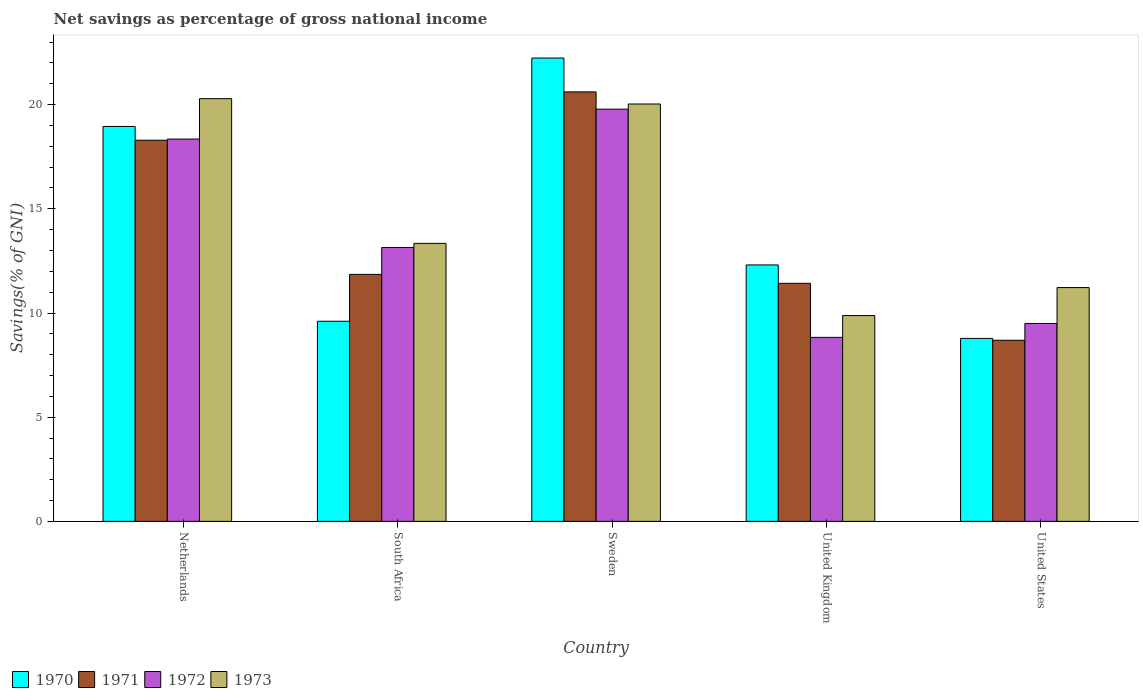How many different coloured bars are there?
Your answer should be very brief. 4. How many groups of bars are there?
Provide a succinct answer. 5. Are the number of bars on each tick of the X-axis equal?
Provide a succinct answer. Yes. What is the label of the 2nd group of bars from the left?
Your answer should be compact. South Africa. In how many cases, is the number of bars for a given country not equal to the number of legend labels?
Offer a very short reply. 0. What is the total savings in 1973 in Sweden?
Your answer should be compact. 20.03. Across all countries, what is the maximum total savings in 1973?
Give a very brief answer. 20.29. Across all countries, what is the minimum total savings in 1973?
Make the answer very short. 9.88. In which country was the total savings in 1971 maximum?
Offer a terse response. Sweden. In which country was the total savings in 1973 minimum?
Provide a short and direct response. United Kingdom. What is the total total savings in 1973 in the graph?
Offer a terse response. 74.76. What is the difference between the total savings in 1973 in South Africa and that in Sweden?
Offer a terse response. -6.69. What is the difference between the total savings in 1972 in Sweden and the total savings in 1971 in South Africa?
Provide a succinct answer. 7.93. What is the average total savings in 1971 per country?
Provide a short and direct response. 14.18. What is the difference between the total savings of/in 1973 and total savings of/in 1970 in Netherlands?
Provide a succinct answer. 1.33. What is the ratio of the total savings in 1973 in Netherlands to that in United Kingdom?
Keep it short and to the point. 2.05. Is the total savings in 1970 in United Kingdom less than that in United States?
Offer a terse response. No. What is the difference between the highest and the second highest total savings in 1970?
Your answer should be very brief. 6.65. What is the difference between the highest and the lowest total savings in 1970?
Your answer should be very brief. 13.46. Is it the case that in every country, the sum of the total savings in 1970 and total savings in 1972 is greater than the total savings in 1971?
Offer a very short reply. Yes. Are all the bars in the graph horizontal?
Ensure brevity in your answer.  No. How many countries are there in the graph?
Offer a terse response. 5. What is the difference between two consecutive major ticks on the Y-axis?
Provide a succinct answer. 5. Does the graph contain grids?
Your response must be concise. No. How many legend labels are there?
Ensure brevity in your answer.  4. What is the title of the graph?
Your answer should be very brief. Net savings as percentage of gross national income. What is the label or title of the X-axis?
Your response must be concise. Country. What is the label or title of the Y-axis?
Your answer should be very brief. Savings(% of GNI). What is the Savings(% of GNI) of 1970 in Netherlands?
Your answer should be compact. 18.95. What is the Savings(% of GNI) in 1971 in Netherlands?
Ensure brevity in your answer.  18.29. What is the Savings(% of GNI) of 1972 in Netherlands?
Your answer should be compact. 18.35. What is the Savings(% of GNI) of 1973 in Netherlands?
Offer a very short reply. 20.29. What is the Savings(% of GNI) of 1970 in South Africa?
Provide a succinct answer. 9.6. What is the Savings(% of GNI) of 1971 in South Africa?
Provide a short and direct response. 11.85. What is the Savings(% of GNI) in 1972 in South Africa?
Provide a short and direct response. 13.14. What is the Savings(% of GNI) in 1973 in South Africa?
Make the answer very short. 13.34. What is the Savings(% of GNI) in 1970 in Sweden?
Give a very brief answer. 22.24. What is the Savings(% of GNI) in 1971 in Sweden?
Ensure brevity in your answer.  20.61. What is the Savings(% of GNI) of 1972 in Sweden?
Offer a very short reply. 19.78. What is the Savings(% of GNI) in 1973 in Sweden?
Make the answer very short. 20.03. What is the Savings(% of GNI) in 1970 in United Kingdom?
Give a very brief answer. 12.31. What is the Savings(% of GNI) of 1971 in United Kingdom?
Your answer should be compact. 11.43. What is the Savings(% of GNI) of 1972 in United Kingdom?
Provide a short and direct response. 8.83. What is the Savings(% of GNI) in 1973 in United Kingdom?
Make the answer very short. 9.88. What is the Savings(% of GNI) of 1970 in United States?
Make the answer very short. 8.78. What is the Savings(% of GNI) of 1971 in United States?
Your answer should be compact. 8.69. What is the Savings(% of GNI) of 1972 in United States?
Provide a short and direct response. 9.5. What is the Savings(% of GNI) in 1973 in United States?
Offer a very short reply. 11.22. Across all countries, what is the maximum Savings(% of GNI) in 1970?
Your response must be concise. 22.24. Across all countries, what is the maximum Savings(% of GNI) of 1971?
Offer a very short reply. 20.61. Across all countries, what is the maximum Savings(% of GNI) in 1972?
Offer a terse response. 19.78. Across all countries, what is the maximum Savings(% of GNI) of 1973?
Keep it short and to the point. 20.29. Across all countries, what is the minimum Savings(% of GNI) in 1970?
Your response must be concise. 8.78. Across all countries, what is the minimum Savings(% of GNI) of 1971?
Keep it short and to the point. 8.69. Across all countries, what is the minimum Savings(% of GNI) of 1972?
Provide a short and direct response. 8.83. Across all countries, what is the minimum Savings(% of GNI) of 1973?
Make the answer very short. 9.88. What is the total Savings(% of GNI) in 1970 in the graph?
Offer a very short reply. 71.88. What is the total Savings(% of GNI) of 1971 in the graph?
Ensure brevity in your answer.  70.88. What is the total Savings(% of GNI) in 1972 in the graph?
Your response must be concise. 69.61. What is the total Savings(% of GNI) in 1973 in the graph?
Make the answer very short. 74.76. What is the difference between the Savings(% of GNI) in 1970 in Netherlands and that in South Africa?
Provide a short and direct response. 9.35. What is the difference between the Savings(% of GNI) of 1971 in Netherlands and that in South Africa?
Make the answer very short. 6.44. What is the difference between the Savings(% of GNI) of 1972 in Netherlands and that in South Africa?
Keep it short and to the point. 5.21. What is the difference between the Savings(% of GNI) in 1973 in Netherlands and that in South Africa?
Keep it short and to the point. 6.95. What is the difference between the Savings(% of GNI) in 1970 in Netherlands and that in Sweden?
Offer a terse response. -3.28. What is the difference between the Savings(% of GNI) in 1971 in Netherlands and that in Sweden?
Provide a succinct answer. -2.32. What is the difference between the Savings(% of GNI) of 1972 in Netherlands and that in Sweden?
Your answer should be compact. -1.43. What is the difference between the Savings(% of GNI) of 1973 in Netherlands and that in Sweden?
Provide a short and direct response. 0.26. What is the difference between the Savings(% of GNI) in 1970 in Netherlands and that in United Kingdom?
Your answer should be compact. 6.65. What is the difference between the Savings(% of GNI) in 1971 in Netherlands and that in United Kingdom?
Offer a very short reply. 6.87. What is the difference between the Savings(% of GNI) of 1972 in Netherlands and that in United Kingdom?
Offer a terse response. 9.52. What is the difference between the Savings(% of GNI) in 1973 in Netherlands and that in United Kingdom?
Keep it short and to the point. 10.41. What is the difference between the Savings(% of GNI) of 1970 in Netherlands and that in United States?
Make the answer very short. 10.17. What is the difference between the Savings(% of GNI) in 1971 in Netherlands and that in United States?
Provide a succinct answer. 9.6. What is the difference between the Savings(% of GNI) of 1972 in Netherlands and that in United States?
Ensure brevity in your answer.  8.85. What is the difference between the Savings(% of GNI) in 1973 in Netherlands and that in United States?
Offer a very short reply. 9.07. What is the difference between the Savings(% of GNI) of 1970 in South Africa and that in Sweden?
Your answer should be compact. -12.63. What is the difference between the Savings(% of GNI) of 1971 in South Africa and that in Sweden?
Provide a short and direct response. -8.76. What is the difference between the Savings(% of GNI) of 1972 in South Africa and that in Sweden?
Offer a terse response. -6.64. What is the difference between the Savings(% of GNI) of 1973 in South Africa and that in Sweden?
Give a very brief answer. -6.69. What is the difference between the Savings(% of GNI) of 1970 in South Africa and that in United Kingdom?
Ensure brevity in your answer.  -2.7. What is the difference between the Savings(% of GNI) in 1971 in South Africa and that in United Kingdom?
Ensure brevity in your answer.  0.43. What is the difference between the Savings(% of GNI) in 1972 in South Africa and that in United Kingdom?
Keep it short and to the point. 4.31. What is the difference between the Savings(% of GNI) in 1973 in South Africa and that in United Kingdom?
Make the answer very short. 3.46. What is the difference between the Savings(% of GNI) of 1970 in South Africa and that in United States?
Keep it short and to the point. 0.82. What is the difference between the Savings(% of GNI) of 1971 in South Africa and that in United States?
Give a very brief answer. 3.16. What is the difference between the Savings(% of GNI) of 1972 in South Africa and that in United States?
Your response must be concise. 3.65. What is the difference between the Savings(% of GNI) of 1973 in South Africa and that in United States?
Your response must be concise. 2.12. What is the difference between the Savings(% of GNI) in 1970 in Sweden and that in United Kingdom?
Make the answer very short. 9.93. What is the difference between the Savings(% of GNI) in 1971 in Sweden and that in United Kingdom?
Ensure brevity in your answer.  9.19. What is the difference between the Savings(% of GNI) in 1972 in Sweden and that in United Kingdom?
Provide a short and direct response. 10.95. What is the difference between the Savings(% of GNI) in 1973 in Sweden and that in United Kingdom?
Your answer should be compact. 10.15. What is the difference between the Savings(% of GNI) in 1970 in Sweden and that in United States?
Your answer should be very brief. 13.46. What is the difference between the Savings(% of GNI) in 1971 in Sweden and that in United States?
Keep it short and to the point. 11.92. What is the difference between the Savings(% of GNI) in 1972 in Sweden and that in United States?
Offer a very short reply. 10.29. What is the difference between the Savings(% of GNI) of 1973 in Sweden and that in United States?
Your answer should be very brief. 8.81. What is the difference between the Savings(% of GNI) of 1970 in United Kingdom and that in United States?
Your answer should be compact. 3.53. What is the difference between the Savings(% of GNI) in 1971 in United Kingdom and that in United States?
Your answer should be compact. 2.73. What is the difference between the Savings(% of GNI) in 1972 in United Kingdom and that in United States?
Provide a short and direct response. -0.67. What is the difference between the Savings(% of GNI) of 1973 in United Kingdom and that in United States?
Provide a short and direct response. -1.34. What is the difference between the Savings(% of GNI) in 1970 in Netherlands and the Savings(% of GNI) in 1971 in South Africa?
Offer a very short reply. 7.1. What is the difference between the Savings(% of GNI) in 1970 in Netherlands and the Savings(% of GNI) in 1972 in South Africa?
Your answer should be compact. 5.81. What is the difference between the Savings(% of GNI) of 1970 in Netherlands and the Savings(% of GNI) of 1973 in South Africa?
Your answer should be very brief. 5.61. What is the difference between the Savings(% of GNI) of 1971 in Netherlands and the Savings(% of GNI) of 1972 in South Africa?
Offer a very short reply. 5.15. What is the difference between the Savings(% of GNI) in 1971 in Netherlands and the Savings(% of GNI) in 1973 in South Africa?
Your response must be concise. 4.95. What is the difference between the Savings(% of GNI) in 1972 in Netherlands and the Savings(% of GNI) in 1973 in South Africa?
Ensure brevity in your answer.  5.01. What is the difference between the Savings(% of GNI) of 1970 in Netherlands and the Savings(% of GNI) of 1971 in Sweden?
Your answer should be very brief. -1.66. What is the difference between the Savings(% of GNI) in 1970 in Netherlands and the Savings(% of GNI) in 1972 in Sweden?
Make the answer very short. -0.83. What is the difference between the Savings(% of GNI) of 1970 in Netherlands and the Savings(% of GNI) of 1973 in Sweden?
Your answer should be compact. -1.08. What is the difference between the Savings(% of GNI) in 1971 in Netherlands and the Savings(% of GNI) in 1972 in Sweden?
Offer a very short reply. -1.49. What is the difference between the Savings(% of GNI) in 1971 in Netherlands and the Savings(% of GNI) in 1973 in Sweden?
Offer a terse response. -1.74. What is the difference between the Savings(% of GNI) of 1972 in Netherlands and the Savings(% of GNI) of 1973 in Sweden?
Offer a very short reply. -1.68. What is the difference between the Savings(% of GNI) of 1970 in Netherlands and the Savings(% of GNI) of 1971 in United Kingdom?
Your answer should be compact. 7.53. What is the difference between the Savings(% of GNI) of 1970 in Netherlands and the Savings(% of GNI) of 1972 in United Kingdom?
Provide a succinct answer. 10.12. What is the difference between the Savings(% of GNI) of 1970 in Netherlands and the Savings(% of GNI) of 1973 in United Kingdom?
Keep it short and to the point. 9.07. What is the difference between the Savings(% of GNI) of 1971 in Netherlands and the Savings(% of GNI) of 1972 in United Kingdom?
Your answer should be very brief. 9.46. What is the difference between the Savings(% of GNI) of 1971 in Netherlands and the Savings(% of GNI) of 1973 in United Kingdom?
Keep it short and to the point. 8.42. What is the difference between the Savings(% of GNI) of 1972 in Netherlands and the Savings(% of GNI) of 1973 in United Kingdom?
Provide a succinct answer. 8.47. What is the difference between the Savings(% of GNI) in 1970 in Netherlands and the Savings(% of GNI) in 1971 in United States?
Your answer should be compact. 10.26. What is the difference between the Savings(% of GNI) of 1970 in Netherlands and the Savings(% of GNI) of 1972 in United States?
Provide a succinct answer. 9.46. What is the difference between the Savings(% of GNI) of 1970 in Netherlands and the Savings(% of GNI) of 1973 in United States?
Your answer should be very brief. 7.73. What is the difference between the Savings(% of GNI) in 1971 in Netherlands and the Savings(% of GNI) in 1972 in United States?
Keep it short and to the point. 8.8. What is the difference between the Savings(% of GNI) in 1971 in Netherlands and the Savings(% of GNI) in 1973 in United States?
Your response must be concise. 7.07. What is the difference between the Savings(% of GNI) of 1972 in Netherlands and the Savings(% of GNI) of 1973 in United States?
Ensure brevity in your answer.  7.13. What is the difference between the Savings(% of GNI) of 1970 in South Africa and the Savings(% of GNI) of 1971 in Sweden?
Ensure brevity in your answer.  -11.01. What is the difference between the Savings(% of GNI) in 1970 in South Africa and the Savings(% of GNI) in 1972 in Sweden?
Offer a very short reply. -10.18. What is the difference between the Savings(% of GNI) in 1970 in South Africa and the Savings(% of GNI) in 1973 in Sweden?
Your answer should be compact. -10.43. What is the difference between the Savings(% of GNI) of 1971 in South Africa and the Savings(% of GNI) of 1972 in Sweden?
Your answer should be compact. -7.93. What is the difference between the Savings(% of GNI) of 1971 in South Africa and the Savings(% of GNI) of 1973 in Sweden?
Your response must be concise. -8.18. What is the difference between the Savings(% of GNI) of 1972 in South Africa and the Savings(% of GNI) of 1973 in Sweden?
Give a very brief answer. -6.89. What is the difference between the Savings(% of GNI) of 1970 in South Africa and the Savings(% of GNI) of 1971 in United Kingdom?
Make the answer very short. -1.82. What is the difference between the Savings(% of GNI) in 1970 in South Africa and the Savings(% of GNI) in 1972 in United Kingdom?
Give a very brief answer. 0.77. What is the difference between the Savings(% of GNI) of 1970 in South Africa and the Savings(% of GNI) of 1973 in United Kingdom?
Provide a succinct answer. -0.27. What is the difference between the Savings(% of GNI) in 1971 in South Africa and the Savings(% of GNI) in 1972 in United Kingdom?
Make the answer very short. 3.02. What is the difference between the Savings(% of GNI) of 1971 in South Africa and the Savings(% of GNI) of 1973 in United Kingdom?
Offer a very short reply. 1.98. What is the difference between the Savings(% of GNI) in 1972 in South Africa and the Savings(% of GNI) in 1973 in United Kingdom?
Your response must be concise. 3.27. What is the difference between the Savings(% of GNI) in 1970 in South Africa and the Savings(% of GNI) in 1971 in United States?
Your response must be concise. 0.91. What is the difference between the Savings(% of GNI) in 1970 in South Africa and the Savings(% of GNI) in 1972 in United States?
Offer a very short reply. 0.11. What is the difference between the Savings(% of GNI) in 1970 in South Africa and the Savings(% of GNI) in 1973 in United States?
Give a very brief answer. -1.62. What is the difference between the Savings(% of GNI) of 1971 in South Africa and the Savings(% of GNI) of 1972 in United States?
Keep it short and to the point. 2.36. What is the difference between the Savings(% of GNI) of 1971 in South Africa and the Savings(% of GNI) of 1973 in United States?
Offer a terse response. 0.63. What is the difference between the Savings(% of GNI) in 1972 in South Africa and the Savings(% of GNI) in 1973 in United States?
Offer a very short reply. 1.92. What is the difference between the Savings(% of GNI) in 1970 in Sweden and the Savings(% of GNI) in 1971 in United Kingdom?
Offer a terse response. 10.81. What is the difference between the Savings(% of GNI) of 1970 in Sweden and the Savings(% of GNI) of 1972 in United Kingdom?
Your response must be concise. 13.41. What is the difference between the Savings(% of GNI) of 1970 in Sweden and the Savings(% of GNI) of 1973 in United Kingdom?
Keep it short and to the point. 12.36. What is the difference between the Savings(% of GNI) in 1971 in Sweden and the Savings(% of GNI) in 1972 in United Kingdom?
Offer a very short reply. 11.78. What is the difference between the Savings(% of GNI) in 1971 in Sweden and the Savings(% of GNI) in 1973 in United Kingdom?
Keep it short and to the point. 10.73. What is the difference between the Savings(% of GNI) of 1972 in Sweden and the Savings(% of GNI) of 1973 in United Kingdom?
Provide a succinct answer. 9.91. What is the difference between the Savings(% of GNI) of 1970 in Sweden and the Savings(% of GNI) of 1971 in United States?
Offer a terse response. 13.54. What is the difference between the Savings(% of GNI) in 1970 in Sweden and the Savings(% of GNI) in 1972 in United States?
Your answer should be very brief. 12.74. What is the difference between the Savings(% of GNI) of 1970 in Sweden and the Savings(% of GNI) of 1973 in United States?
Provide a succinct answer. 11.02. What is the difference between the Savings(% of GNI) of 1971 in Sweden and the Savings(% of GNI) of 1972 in United States?
Your answer should be compact. 11.12. What is the difference between the Savings(% of GNI) of 1971 in Sweden and the Savings(% of GNI) of 1973 in United States?
Your answer should be compact. 9.39. What is the difference between the Savings(% of GNI) of 1972 in Sweden and the Savings(% of GNI) of 1973 in United States?
Ensure brevity in your answer.  8.56. What is the difference between the Savings(% of GNI) in 1970 in United Kingdom and the Savings(% of GNI) in 1971 in United States?
Provide a succinct answer. 3.62. What is the difference between the Savings(% of GNI) in 1970 in United Kingdom and the Savings(% of GNI) in 1972 in United States?
Provide a succinct answer. 2.81. What is the difference between the Savings(% of GNI) of 1970 in United Kingdom and the Savings(% of GNI) of 1973 in United States?
Your answer should be compact. 1.09. What is the difference between the Savings(% of GNI) of 1971 in United Kingdom and the Savings(% of GNI) of 1972 in United States?
Your answer should be compact. 1.93. What is the difference between the Savings(% of GNI) in 1971 in United Kingdom and the Savings(% of GNI) in 1973 in United States?
Offer a very short reply. 0.2. What is the difference between the Savings(% of GNI) in 1972 in United Kingdom and the Savings(% of GNI) in 1973 in United States?
Provide a short and direct response. -2.39. What is the average Savings(% of GNI) in 1970 per country?
Provide a succinct answer. 14.38. What is the average Savings(% of GNI) of 1971 per country?
Give a very brief answer. 14.18. What is the average Savings(% of GNI) of 1972 per country?
Offer a terse response. 13.92. What is the average Savings(% of GNI) in 1973 per country?
Ensure brevity in your answer.  14.95. What is the difference between the Savings(% of GNI) of 1970 and Savings(% of GNI) of 1971 in Netherlands?
Your response must be concise. 0.66. What is the difference between the Savings(% of GNI) in 1970 and Savings(% of GNI) in 1972 in Netherlands?
Ensure brevity in your answer.  0.6. What is the difference between the Savings(% of GNI) of 1970 and Savings(% of GNI) of 1973 in Netherlands?
Provide a short and direct response. -1.33. What is the difference between the Savings(% of GNI) of 1971 and Savings(% of GNI) of 1972 in Netherlands?
Offer a very short reply. -0.06. What is the difference between the Savings(% of GNI) in 1971 and Savings(% of GNI) in 1973 in Netherlands?
Your answer should be very brief. -1.99. What is the difference between the Savings(% of GNI) of 1972 and Savings(% of GNI) of 1973 in Netherlands?
Your answer should be compact. -1.94. What is the difference between the Savings(% of GNI) in 1970 and Savings(% of GNI) in 1971 in South Africa?
Ensure brevity in your answer.  -2.25. What is the difference between the Savings(% of GNI) in 1970 and Savings(% of GNI) in 1972 in South Africa?
Ensure brevity in your answer.  -3.54. What is the difference between the Savings(% of GNI) in 1970 and Savings(% of GNI) in 1973 in South Africa?
Keep it short and to the point. -3.74. What is the difference between the Savings(% of GNI) in 1971 and Savings(% of GNI) in 1972 in South Africa?
Your response must be concise. -1.29. What is the difference between the Savings(% of GNI) in 1971 and Savings(% of GNI) in 1973 in South Africa?
Offer a very short reply. -1.49. What is the difference between the Savings(% of GNI) in 1972 and Savings(% of GNI) in 1973 in South Africa?
Offer a very short reply. -0.2. What is the difference between the Savings(% of GNI) of 1970 and Savings(% of GNI) of 1971 in Sweden?
Your answer should be very brief. 1.62. What is the difference between the Savings(% of GNI) of 1970 and Savings(% of GNI) of 1972 in Sweden?
Your answer should be compact. 2.45. What is the difference between the Savings(% of GNI) in 1970 and Savings(% of GNI) in 1973 in Sweden?
Provide a short and direct response. 2.21. What is the difference between the Savings(% of GNI) of 1971 and Savings(% of GNI) of 1972 in Sweden?
Your answer should be compact. 0.83. What is the difference between the Savings(% of GNI) in 1971 and Savings(% of GNI) in 1973 in Sweden?
Offer a terse response. 0.58. What is the difference between the Savings(% of GNI) in 1972 and Savings(% of GNI) in 1973 in Sweden?
Your answer should be compact. -0.25. What is the difference between the Savings(% of GNI) of 1970 and Savings(% of GNI) of 1971 in United Kingdom?
Provide a succinct answer. 0.88. What is the difference between the Savings(% of GNI) of 1970 and Savings(% of GNI) of 1972 in United Kingdom?
Make the answer very short. 3.48. What is the difference between the Savings(% of GNI) in 1970 and Savings(% of GNI) in 1973 in United Kingdom?
Your answer should be compact. 2.43. What is the difference between the Savings(% of GNI) in 1971 and Savings(% of GNI) in 1972 in United Kingdom?
Offer a terse response. 2.59. What is the difference between the Savings(% of GNI) in 1971 and Savings(% of GNI) in 1973 in United Kingdom?
Keep it short and to the point. 1.55. What is the difference between the Savings(% of GNI) of 1972 and Savings(% of GNI) of 1973 in United Kingdom?
Keep it short and to the point. -1.05. What is the difference between the Savings(% of GNI) in 1970 and Savings(% of GNI) in 1971 in United States?
Provide a short and direct response. 0.09. What is the difference between the Savings(% of GNI) of 1970 and Savings(% of GNI) of 1972 in United States?
Provide a short and direct response. -0.72. What is the difference between the Savings(% of GNI) of 1970 and Savings(% of GNI) of 1973 in United States?
Ensure brevity in your answer.  -2.44. What is the difference between the Savings(% of GNI) in 1971 and Savings(% of GNI) in 1972 in United States?
Make the answer very short. -0.81. What is the difference between the Savings(% of GNI) in 1971 and Savings(% of GNI) in 1973 in United States?
Keep it short and to the point. -2.53. What is the difference between the Savings(% of GNI) of 1972 and Savings(% of GNI) of 1973 in United States?
Provide a succinct answer. -1.72. What is the ratio of the Savings(% of GNI) in 1970 in Netherlands to that in South Africa?
Keep it short and to the point. 1.97. What is the ratio of the Savings(% of GNI) in 1971 in Netherlands to that in South Africa?
Make the answer very short. 1.54. What is the ratio of the Savings(% of GNI) in 1972 in Netherlands to that in South Africa?
Offer a terse response. 1.4. What is the ratio of the Savings(% of GNI) of 1973 in Netherlands to that in South Africa?
Provide a short and direct response. 1.52. What is the ratio of the Savings(% of GNI) of 1970 in Netherlands to that in Sweden?
Offer a terse response. 0.85. What is the ratio of the Savings(% of GNI) of 1971 in Netherlands to that in Sweden?
Offer a very short reply. 0.89. What is the ratio of the Savings(% of GNI) in 1972 in Netherlands to that in Sweden?
Your answer should be very brief. 0.93. What is the ratio of the Savings(% of GNI) in 1973 in Netherlands to that in Sweden?
Give a very brief answer. 1.01. What is the ratio of the Savings(% of GNI) in 1970 in Netherlands to that in United Kingdom?
Keep it short and to the point. 1.54. What is the ratio of the Savings(% of GNI) of 1971 in Netherlands to that in United Kingdom?
Your answer should be compact. 1.6. What is the ratio of the Savings(% of GNI) in 1972 in Netherlands to that in United Kingdom?
Provide a short and direct response. 2.08. What is the ratio of the Savings(% of GNI) of 1973 in Netherlands to that in United Kingdom?
Provide a short and direct response. 2.05. What is the ratio of the Savings(% of GNI) in 1970 in Netherlands to that in United States?
Your answer should be compact. 2.16. What is the ratio of the Savings(% of GNI) of 1971 in Netherlands to that in United States?
Your answer should be very brief. 2.1. What is the ratio of the Savings(% of GNI) of 1972 in Netherlands to that in United States?
Provide a short and direct response. 1.93. What is the ratio of the Savings(% of GNI) of 1973 in Netherlands to that in United States?
Make the answer very short. 1.81. What is the ratio of the Savings(% of GNI) of 1970 in South Africa to that in Sweden?
Your answer should be very brief. 0.43. What is the ratio of the Savings(% of GNI) in 1971 in South Africa to that in Sweden?
Provide a succinct answer. 0.58. What is the ratio of the Savings(% of GNI) in 1972 in South Africa to that in Sweden?
Provide a succinct answer. 0.66. What is the ratio of the Savings(% of GNI) in 1973 in South Africa to that in Sweden?
Keep it short and to the point. 0.67. What is the ratio of the Savings(% of GNI) in 1970 in South Africa to that in United Kingdom?
Ensure brevity in your answer.  0.78. What is the ratio of the Savings(% of GNI) in 1971 in South Africa to that in United Kingdom?
Give a very brief answer. 1.04. What is the ratio of the Savings(% of GNI) in 1972 in South Africa to that in United Kingdom?
Offer a very short reply. 1.49. What is the ratio of the Savings(% of GNI) in 1973 in South Africa to that in United Kingdom?
Provide a short and direct response. 1.35. What is the ratio of the Savings(% of GNI) of 1970 in South Africa to that in United States?
Give a very brief answer. 1.09. What is the ratio of the Savings(% of GNI) in 1971 in South Africa to that in United States?
Your response must be concise. 1.36. What is the ratio of the Savings(% of GNI) in 1972 in South Africa to that in United States?
Your answer should be compact. 1.38. What is the ratio of the Savings(% of GNI) in 1973 in South Africa to that in United States?
Your answer should be very brief. 1.19. What is the ratio of the Savings(% of GNI) of 1970 in Sweden to that in United Kingdom?
Offer a terse response. 1.81. What is the ratio of the Savings(% of GNI) of 1971 in Sweden to that in United Kingdom?
Give a very brief answer. 1.8. What is the ratio of the Savings(% of GNI) of 1972 in Sweden to that in United Kingdom?
Provide a succinct answer. 2.24. What is the ratio of the Savings(% of GNI) of 1973 in Sweden to that in United Kingdom?
Offer a very short reply. 2.03. What is the ratio of the Savings(% of GNI) in 1970 in Sweden to that in United States?
Provide a succinct answer. 2.53. What is the ratio of the Savings(% of GNI) in 1971 in Sweden to that in United States?
Give a very brief answer. 2.37. What is the ratio of the Savings(% of GNI) in 1972 in Sweden to that in United States?
Your answer should be very brief. 2.08. What is the ratio of the Savings(% of GNI) of 1973 in Sweden to that in United States?
Ensure brevity in your answer.  1.79. What is the ratio of the Savings(% of GNI) of 1970 in United Kingdom to that in United States?
Provide a succinct answer. 1.4. What is the ratio of the Savings(% of GNI) of 1971 in United Kingdom to that in United States?
Offer a terse response. 1.31. What is the ratio of the Savings(% of GNI) in 1972 in United Kingdom to that in United States?
Keep it short and to the point. 0.93. What is the ratio of the Savings(% of GNI) of 1973 in United Kingdom to that in United States?
Provide a succinct answer. 0.88. What is the difference between the highest and the second highest Savings(% of GNI) in 1970?
Provide a succinct answer. 3.28. What is the difference between the highest and the second highest Savings(% of GNI) of 1971?
Make the answer very short. 2.32. What is the difference between the highest and the second highest Savings(% of GNI) of 1972?
Your answer should be compact. 1.43. What is the difference between the highest and the second highest Savings(% of GNI) of 1973?
Your response must be concise. 0.26. What is the difference between the highest and the lowest Savings(% of GNI) in 1970?
Provide a short and direct response. 13.46. What is the difference between the highest and the lowest Savings(% of GNI) of 1971?
Your response must be concise. 11.92. What is the difference between the highest and the lowest Savings(% of GNI) in 1972?
Keep it short and to the point. 10.95. What is the difference between the highest and the lowest Savings(% of GNI) of 1973?
Your answer should be compact. 10.41. 